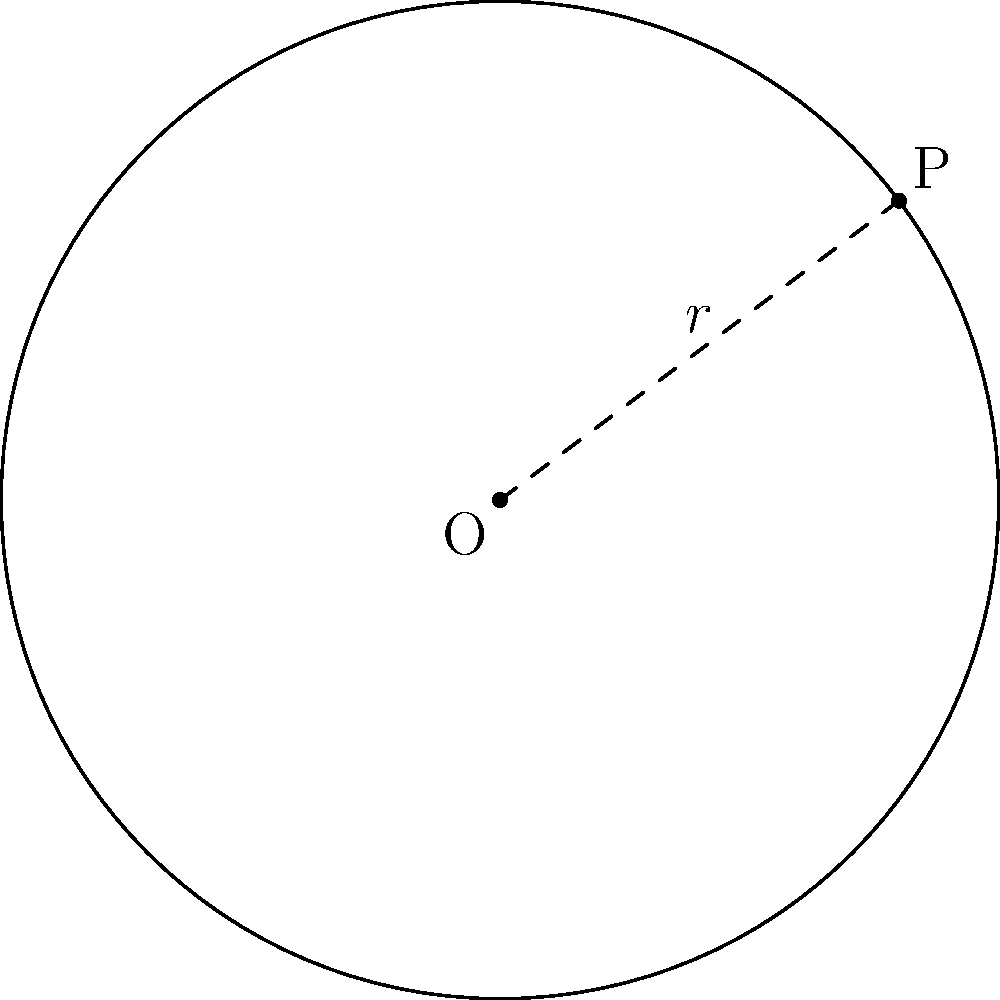In the digital cataloging system, we often use coordinate geometry to map out the locations of books. Consider a circular reading area in the library. The center of this area is at point O(2,3), and a point P(6,6) lies on its circumference. What is the equation of the circle representing this reading area? Let's approach this step-by-step:

1) The general equation of a circle is $$(x-h)^2 + (y-k)^2 = r^2$$
   where (h,k) is the center and r is the radius.

2) We're given the center O(2,3), so h=2 and k=3.

3) To find r, we need to calculate the distance between O(2,3) and P(6,6):
   
   $$r^2 = (x_P - x_O)^2 + (y_P - y_O)^2$$
   $$r^2 = (6 - 2)^2 + (6 - 3)^2$$
   $$r^2 = 4^2 + 3^2 = 16 + 9 = 25$$
   $$r = 5$$

4) Now we have all the components to write the equation:

   $$(x-2)^2 + (y-3)^2 = 5^2$$

5) Expanding the right side:

   $$(x-2)^2 + (y-3)^2 = 25$$

This is the equation of the circle representing the reading area.
Answer: $$(x-2)^2 + (y-3)^2 = 25$$ 